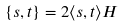Convert formula to latex. <formula><loc_0><loc_0><loc_500><loc_500>\{ s , t \} = 2 \langle s , t \rangle H</formula> 